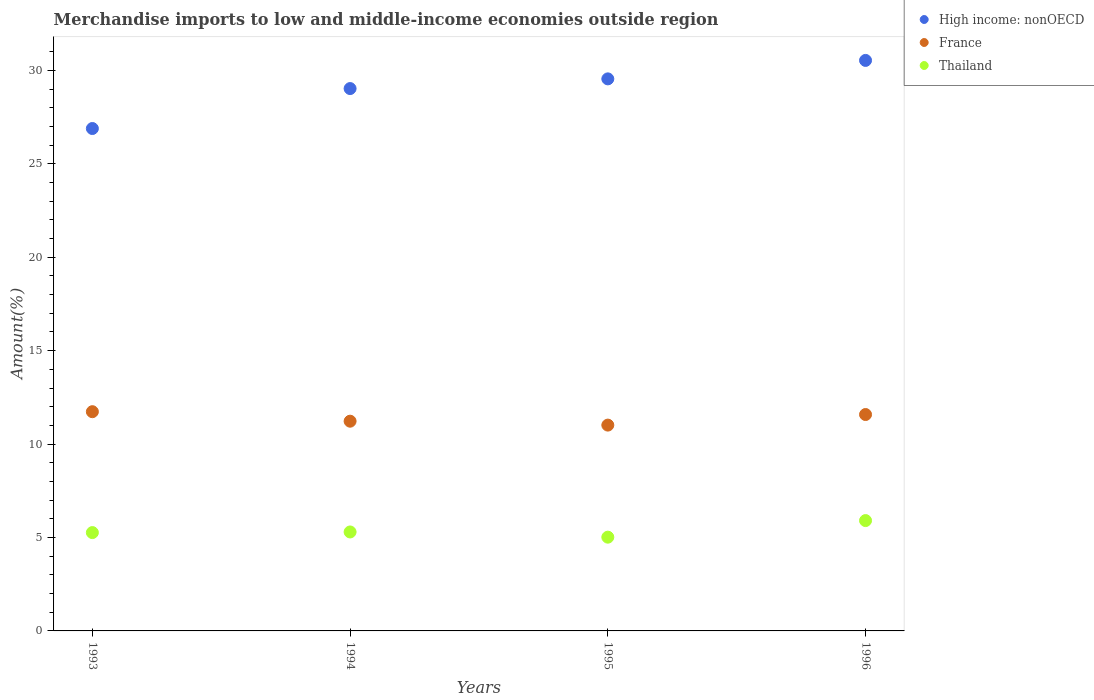How many different coloured dotlines are there?
Keep it short and to the point. 3. What is the percentage of amount earned from merchandise imports in Thailand in 1993?
Your response must be concise. 5.26. Across all years, what is the maximum percentage of amount earned from merchandise imports in Thailand?
Ensure brevity in your answer.  5.91. Across all years, what is the minimum percentage of amount earned from merchandise imports in France?
Give a very brief answer. 11.01. In which year was the percentage of amount earned from merchandise imports in High income: nonOECD maximum?
Keep it short and to the point. 1996. In which year was the percentage of amount earned from merchandise imports in High income: nonOECD minimum?
Ensure brevity in your answer.  1993. What is the total percentage of amount earned from merchandise imports in France in the graph?
Your answer should be compact. 45.55. What is the difference between the percentage of amount earned from merchandise imports in Thailand in 1994 and that in 1995?
Your answer should be compact. 0.28. What is the difference between the percentage of amount earned from merchandise imports in Thailand in 1993 and the percentage of amount earned from merchandise imports in France in 1996?
Your response must be concise. -6.32. What is the average percentage of amount earned from merchandise imports in France per year?
Offer a terse response. 11.39. In the year 1994, what is the difference between the percentage of amount earned from merchandise imports in Thailand and percentage of amount earned from merchandise imports in France?
Give a very brief answer. -5.93. What is the ratio of the percentage of amount earned from merchandise imports in France in 1994 to that in 1995?
Provide a succinct answer. 1.02. Is the percentage of amount earned from merchandise imports in Thailand in 1993 less than that in 1996?
Make the answer very short. Yes. What is the difference between the highest and the second highest percentage of amount earned from merchandise imports in Thailand?
Make the answer very short. 0.61. What is the difference between the highest and the lowest percentage of amount earned from merchandise imports in Thailand?
Your answer should be compact. 0.89. Is the sum of the percentage of amount earned from merchandise imports in France in 1995 and 1996 greater than the maximum percentage of amount earned from merchandise imports in Thailand across all years?
Your response must be concise. Yes. How many years are there in the graph?
Ensure brevity in your answer.  4. Are the values on the major ticks of Y-axis written in scientific E-notation?
Offer a terse response. No. Does the graph contain any zero values?
Offer a very short reply. No. How many legend labels are there?
Provide a short and direct response. 3. What is the title of the graph?
Ensure brevity in your answer.  Merchandise imports to low and middle-income economies outside region. Does "Kuwait" appear as one of the legend labels in the graph?
Offer a terse response. No. What is the label or title of the Y-axis?
Give a very brief answer. Amount(%). What is the Amount(%) in High income: nonOECD in 1993?
Provide a short and direct response. 26.89. What is the Amount(%) in France in 1993?
Offer a terse response. 11.73. What is the Amount(%) of Thailand in 1993?
Offer a very short reply. 5.26. What is the Amount(%) of High income: nonOECD in 1994?
Provide a short and direct response. 29.03. What is the Amount(%) of France in 1994?
Your response must be concise. 11.22. What is the Amount(%) in Thailand in 1994?
Offer a terse response. 5.3. What is the Amount(%) in High income: nonOECD in 1995?
Your answer should be compact. 29.54. What is the Amount(%) of France in 1995?
Your answer should be very brief. 11.01. What is the Amount(%) in Thailand in 1995?
Provide a succinct answer. 5.02. What is the Amount(%) in High income: nonOECD in 1996?
Your response must be concise. 30.53. What is the Amount(%) in France in 1996?
Give a very brief answer. 11.58. What is the Amount(%) of Thailand in 1996?
Make the answer very short. 5.91. Across all years, what is the maximum Amount(%) of High income: nonOECD?
Keep it short and to the point. 30.53. Across all years, what is the maximum Amount(%) in France?
Offer a very short reply. 11.73. Across all years, what is the maximum Amount(%) in Thailand?
Your answer should be very brief. 5.91. Across all years, what is the minimum Amount(%) in High income: nonOECD?
Make the answer very short. 26.89. Across all years, what is the minimum Amount(%) in France?
Provide a short and direct response. 11.01. Across all years, what is the minimum Amount(%) of Thailand?
Offer a terse response. 5.02. What is the total Amount(%) in High income: nonOECD in the graph?
Make the answer very short. 115.99. What is the total Amount(%) of France in the graph?
Offer a terse response. 45.55. What is the total Amount(%) of Thailand in the graph?
Your answer should be compact. 21.48. What is the difference between the Amount(%) in High income: nonOECD in 1993 and that in 1994?
Ensure brevity in your answer.  -2.14. What is the difference between the Amount(%) of France in 1993 and that in 1994?
Ensure brevity in your answer.  0.51. What is the difference between the Amount(%) of Thailand in 1993 and that in 1994?
Keep it short and to the point. -0.03. What is the difference between the Amount(%) in High income: nonOECD in 1993 and that in 1995?
Give a very brief answer. -2.66. What is the difference between the Amount(%) in France in 1993 and that in 1995?
Your response must be concise. 0.72. What is the difference between the Amount(%) of Thailand in 1993 and that in 1995?
Give a very brief answer. 0.24. What is the difference between the Amount(%) in High income: nonOECD in 1993 and that in 1996?
Give a very brief answer. -3.64. What is the difference between the Amount(%) of France in 1993 and that in 1996?
Give a very brief answer. 0.15. What is the difference between the Amount(%) of Thailand in 1993 and that in 1996?
Provide a succinct answer. -0.64. What is the difference between the Amount(%) in High income: nonOECD in 1994 and that in 1995?
Offer a terse response. -0.52. What is the difference between the Amount(%) of France in 1994 and that in 1995?
Provide a short and direct response. 0.21. What is the difference between the Amount(%) of Thailand in 1994 and that in 1995?
Your response must be concise. 0.28. What is the difference between the Amount(%) of High income: nonOECD in 1994 and that in 1996?
Your response must be concise. -1.51. What is the difference between the Amount(%) of France in 1994 and that in 1996?
Make the answer very short. -0.36. What is the difference between the Amount(%) in Thailand in 1994 and that in 1996?
Your answer should be very brief. -0.61. What is the difference between the Amount(%) of High income: nonOECD in 1995 and that in 1996?
Provide a short and direct response. -0.99. What is the difference between the Amount(%) in France in 1995 and that in 1996?
Make the answer very short. -0.57. What is the difference between the Amount(%) in Thailand in 1995 and that in 1996?
Your answer should be compact. -0.89. What is the difference between the Amount(%) of High income: nonOECD in 1993 and the Amount(%) of France in 1994?
Keep it short and to the point. 15.66. What is the difference between the Amount(%) of High income: nonOECD in 1993 and the Amount(%) of Thailand in 1994?
Your response must be concise. 21.59. What is the difference between the Amount(%) in France in 1993 and the Amount(%) in Thailand in 1994?
Your answer should be compact. 6.44. What is the difference between the Amount(%) in High income: nonOECD in 1993 and the Amount(%) in France in 1995?
Make the answer very short. 15.87. What is the difference between the Amount(%) of High income: nonOECD in 1993 and the Amount(%) of Thailand in 1995?
Your answer should be very brief. 21.87. What is the difference between the Amount(%) in France in 1993 and the Amount(%) in Thailand in 1995?
Your response must be concise. 6.72. What is the difference between the Amount(%) of High income: nonOECD in 1993 and the Amount(%) of France in 1996?
Provide a succinct answer. 15.31. What is the difference between the Amount(%) in High income: nonOECD in 1993 and the Amount(%) in Thailand in 1996?
Ensure brevity in your answer.  20.98. What is the difference between the Amount(%) in France in 1993 and the Amount(%) in Thailand in 1996?
Your answer should be very brief. 5.83. What is the difference between the Amount(%) in High income: nonOECD in 1994 and the Amount(%) in France in 1995?
Offer a very short reply. 18.01. What is the difference between the Amount(%) of High income: nonOECD in 1994 and the Amount(%) of Thailand in 1995?
Ensure brevity in your answer.  24.01. What is the difference between the Amount(%) in France in 1994 and the Amount(%) in Thailand in 1995?
Provide a short and direct response. 6.21. What is the difference between the Amount(%) of High income: nonOECD in 1994 and the Amount(%) of France in 1996?
Provide a short and direct response. 17.45. What is the difference between the Amount(%) in High income: nonOECD in 1994 and the Amount(%) in Thailand in 1996?
Offer a very short reply. 23.12. What is the difference between the Amount(%) of France in 1994 and the Amount(%) of Thailand in 1996?
Your response must be concise. 5.32. What is the difference between the Amount(%) of High income: nonOECD in 1995 and the Amount(%) of France in 1996?
Keep it short and to the point. 17.96. What is the difference between the Amount(%) of High income: nonOECD in 1995 and the Amount(%) of Thailand in 1996?
Provide a short and direct response. 23.64. What is the difference between the Amount(%) in France in 1995 and the Amount(%) in Thailand in 1996?
Keep it short and to the point. 5.11. What is the average Amount(%) in High income: nonOECD per year?
Your response must be concise. 29. What is the average Amount(%) in France per year?
Your answer should be very brief. 11.39. What is the average Amount(%) in Thailand per year?
Make the answer very short. 5.37. In the year 1993, what is the difference between the Amount(%) of High income: nonOECD and Amount(%) of France?
Your answer should be very brief. 15.15. In the year 1993, what is the difference between the Amount(%) of High income: nonOECD and Amount(%) of Thailand?
Make the answer very short. 21.63. In the year 1993, what is the difference between the Amount(%) of France and Amount(%) of Thailand?
Your answer should be very brief. 6.47. In the year 1994, what is the difference between the Amount(%) of High income: nonOECD and Amount(%) of France?
Give a very brief answer. 17.8. In the year 1994, what is the difference between the Amount(%) in High income: nonOECD and Amount(%) in Thailand?
Offer a very short reply. 23.73. In the year 1994, what is the difference between the Amount(%) in France and Amount(%) in Thailand?
Provide a short and direct response. 5.93. In the year 1995, what is the difference between the Amount(%) of High income: nonOECD and Amount(%) of France?
Provide a short and direct response. 18.53. In the year 1995, what is the difference between the Amount(%) of High income: nonOECD and Amount(%) of Thailand?
Your response must be concise. 24.53. In the year 1995, what is the difference between the Amount(%) in France and Amount(%) in Thailand?
Offer a terse response. 6. In the year 1996, what is the difference between the Amount(%) of High income: nonOECD and Amount(%) of France?
Provide a succinct answer. 18.95. In the year 1996, what is the difference between the Amount(%) of High income: nonOECD and Amount(%) of Thailand?
Ensure brevity in your answer.  24.63. In the year 1996, what is the difference between the Amount(%) in France and Amount(%) in Thailand?
Keep it short and to the point. 5.68. What is the ratio of the Amount(%) in High income: nonOECD in 1993 to that in 1994?
Provide a short and direct response. 0.93. What is the ratio of the Amount(%) in France in 1993 to that in 1994?
Your answer should be very brief. 1.05. What is the ratio of the Amount(%) of Thailand in 1993 to that in 1994?
Keep it short and to the point. 0.99. What is the ratio of the Amount(%) of High income: nonOECD in 1993 to that in 1995?
Ensure brevity in your answer.  0.91. What is the ratio of the Amount(%) in France in 1993 to that in 1995?
Your answer should be compact. 1.07. What is the ratio of the Amount(%) of Thailand in 1993 to that in 1995?
Offer a very short reply. 1.05. What is the ratio of the Amount(%) of High income: nonOECD in 1993 to that in 1996?
Provide a succinct answer. 0.88. What is the ratio of the Amount(%) of France in 1993 to that in 1996?
Offer a very short reply. 1.01. What is the ratio of the Amount(%) in Thailand in 1993 to that in 1996?
Offer a terse response. 0.89. What is the ratio of the Amount(%) in High income: nonOECD in 1994 to that in 1995?
Your answer should be very brief. 0.98. What is the ratio of the Amount(%) of Thailand in 1994 to that in 1995?
Offer a very short reply. 1.06. What is the ratio of the Amount(%) of High income: nonOECD in 1994 to that in 1996?
Ensure brevity in your answer.  0.95. What is the ratio of the Amount(%) in France in 1994 to that in 1996?
Ensure brevity in your answer.  0.97. What is the ratio of the Amount(%) of Thailand in 1994 to that in 1996?
Give a very brief answer. 0.9. What is the ratio of the Amount(%) in High income: nonOECD in 1995 to that in 1996?
Provide a short and direct response. 0.97. What is the ratio of the Amount(%) of France in 1995 to that in 1996?
Your response must be concise. 0.95. What is the ratio of the Amount(%) in Thailand in 1995 to that in 1996?
Give a very brief answer. 0.85. What is the difference between the highest and the second highest Amount(%) of France?
Your answer should be compact. 0.15. What is the difference between the highest and the second highest Amount(%) of Thailand?
Give a very brief answer. 0.61. What is the difference between the highest and the lowest Amount(%) in High income: nonOECD?
Provide a succinct answer. 3.64. What is the difference between the highest and the lowest Amount(%) of France?
Ensure brevity in your answer.  0.72. What is the difference between the highest and the lowest Amount(%) in Thailand?
Your answer should be compact. 0.89. 